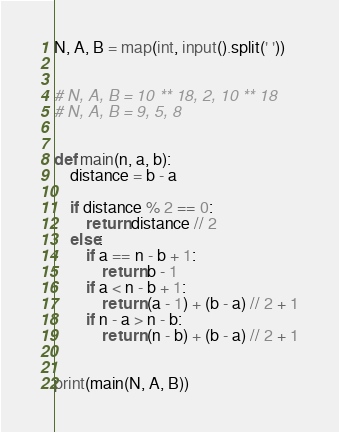Convert code to text. <code><loc_0><loc_0><loc_500><loc_500><_Python_>N, A, B = map(int, input().split(' '))


# N, A, B = 10 ** 18, 2, 10 ** 18
# N, A, B = 9, 5, 8


def main(n, a, b):
    distance = b - a

    if distance % 2 == 0:
        return distance // 2
    else:
        if a == n - b + 1:
            return b - 1
        if a < n - b + 1:
            return (a - 1) + (b - a) // 2 + 1
        if n - a > n - b:
            return (n - b) + (b - a) // 2 + 1


print(main(N, A, B))
</code> 